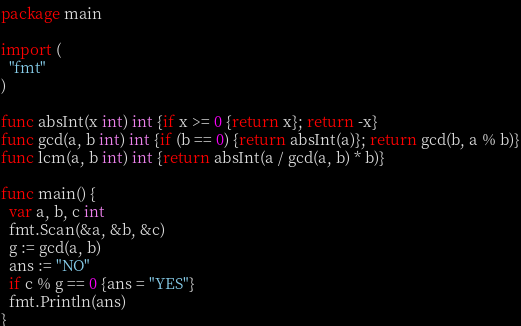<code> <loc_0><loc_0><loc_500><loc_500><_Go_>package main

import (
  "fmt"
)

func absInt(x int) int {if x >= 0 {return x}; return -x}
func gcd(a, b int) int {if (b == 0) {return absInt(a)}; return gcd(b, a % b)}
func lcm(a, b int) int {return absInt(a / gcd(a, b) * b)}

func main() {
  var a, b, c int 
  fmt.Scan(&a, &b, &c)
  g := gcd(a, b)
  ans := "NO"
  if c % g == 0 {ans = "YES"}
  fmt.Println(ans)
}</code> 